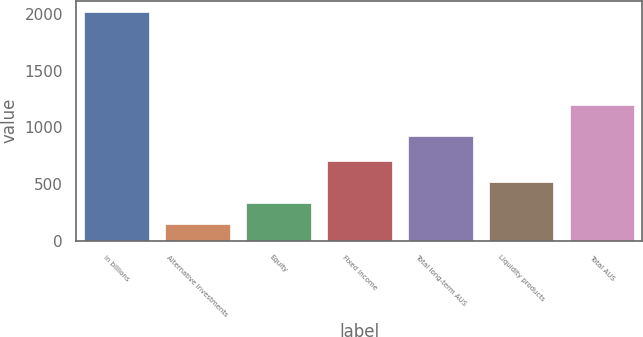Convert chart to OTSL. <chart><loc_0><loc_0><loc_500><loc_500><bar_chart><fcel>in billions<fcel>Alternative investments<fcel>Equity<fcel>Fixed income<fcel>Total long-term AUS<fcel>Liquidity products<fcel>Total AUS<nl><fcel>2015<fcel>145<fcel>332<fcel>706<fcel>922<fcel>519<fcel>1194<nl></chart> 